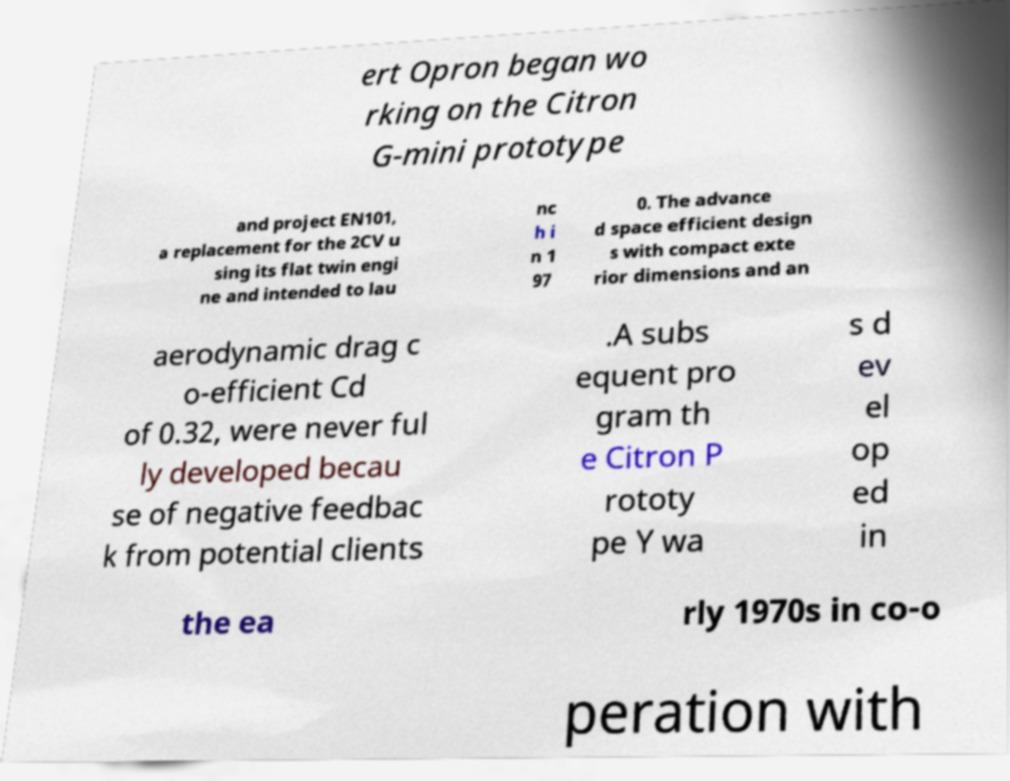There's text embedded in this image that I need extracted. Can you transcribe it verbatim? ert Opron began wo rking on the Citron G-mini prototype and project EN101, a replacement for the 2CV u sing its flat twin engi ne and intended to lau nc h i n 1 97 0. The advance d space efficient design s with compact exte rior dimensions and an aerodynamic drag c o-efficient Cd of 0.32, were never ful ly developed becau se of negative feedbac k from potential clients .A subs equent pro gram th e Citron P rototy pe Y wa s d ev el op ed in the ea rly 1970s in co-o peration with 